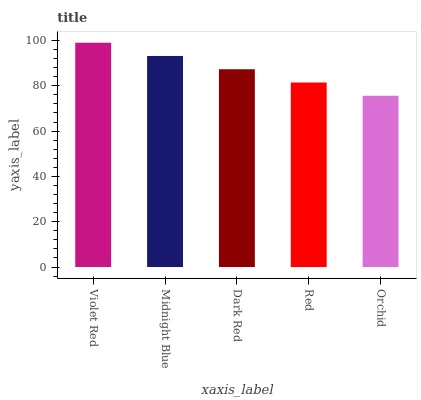Is Orchid the minimum?
Answer yes or no. Yes. Is Violet Red the maximum?
Answer yes or no. Yes. Is Midnight Blue the minimum?
Answer yes or no. No. Is Midnight Blue the maximum?
Answer yes or no. No. Is Violet Red greater than Midnight Blue?
Answer yes or no. Yes. Is Midnight Blue less than Violet Red?
Answer yes or no. Yes. Is Midnight Blue greater than Violet Red?
Answer yes or no. No. Is Violet Red less than Midnight Blue?
Answer yes or no. No. Is Dark Red the high median?
Answer yes or no. Yes. Is Dark Red the low median?
Answer yes or no. Yes. Is Red the high median?
Answer yes or no. No. Is Midnight Blue the low median?
Answer yes or no. No. 